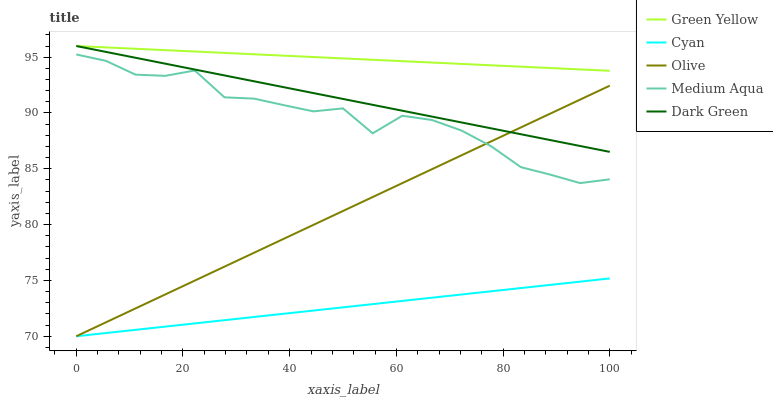Does Cyan have the minimum area under the curve?
Answer yes or no. Yes. Does Green Yellow have the maximum area under the curve?
Answer yes or no. Yes. Does Green Yellow have the minimum area under the curve?
Answer yes or no. No. Does Cyan have the maximum area under the curve?
Answer yes or no. No. Is Dark Green the smoothest?
Answer yes or no. Yes. Is Medium Aqua the roughest?
Answer yes or no. Yes. Is Cyan the smoothest?
Answer yes or no. No. Is Cyan the roughest?
Answer yes or no. No. Does Olive have the lowest value?
Answer yes or no. Yes. Does Green Yellow have the lowest value?
Answer yes or no. No. Does Dark Green have the highest value?
Answer yes or no. Yes. Does Cyan have the highest value?
Answer yes or no. No. Is Cyan less than Green Yellow?
Answer yes or no. Yes. Is Dark Green greater than Medium Aqua?
Answer yes or no. Yes. Does Olive intersect Cyan?
Answer yes or no. Yes. Is Olive less than Cyan?
Answer yes or no. No. Is Olive greater than Cyan?
Answer yes or no. No. Does Cyan intersect Green Yellow?
Answer yes or no. No. 